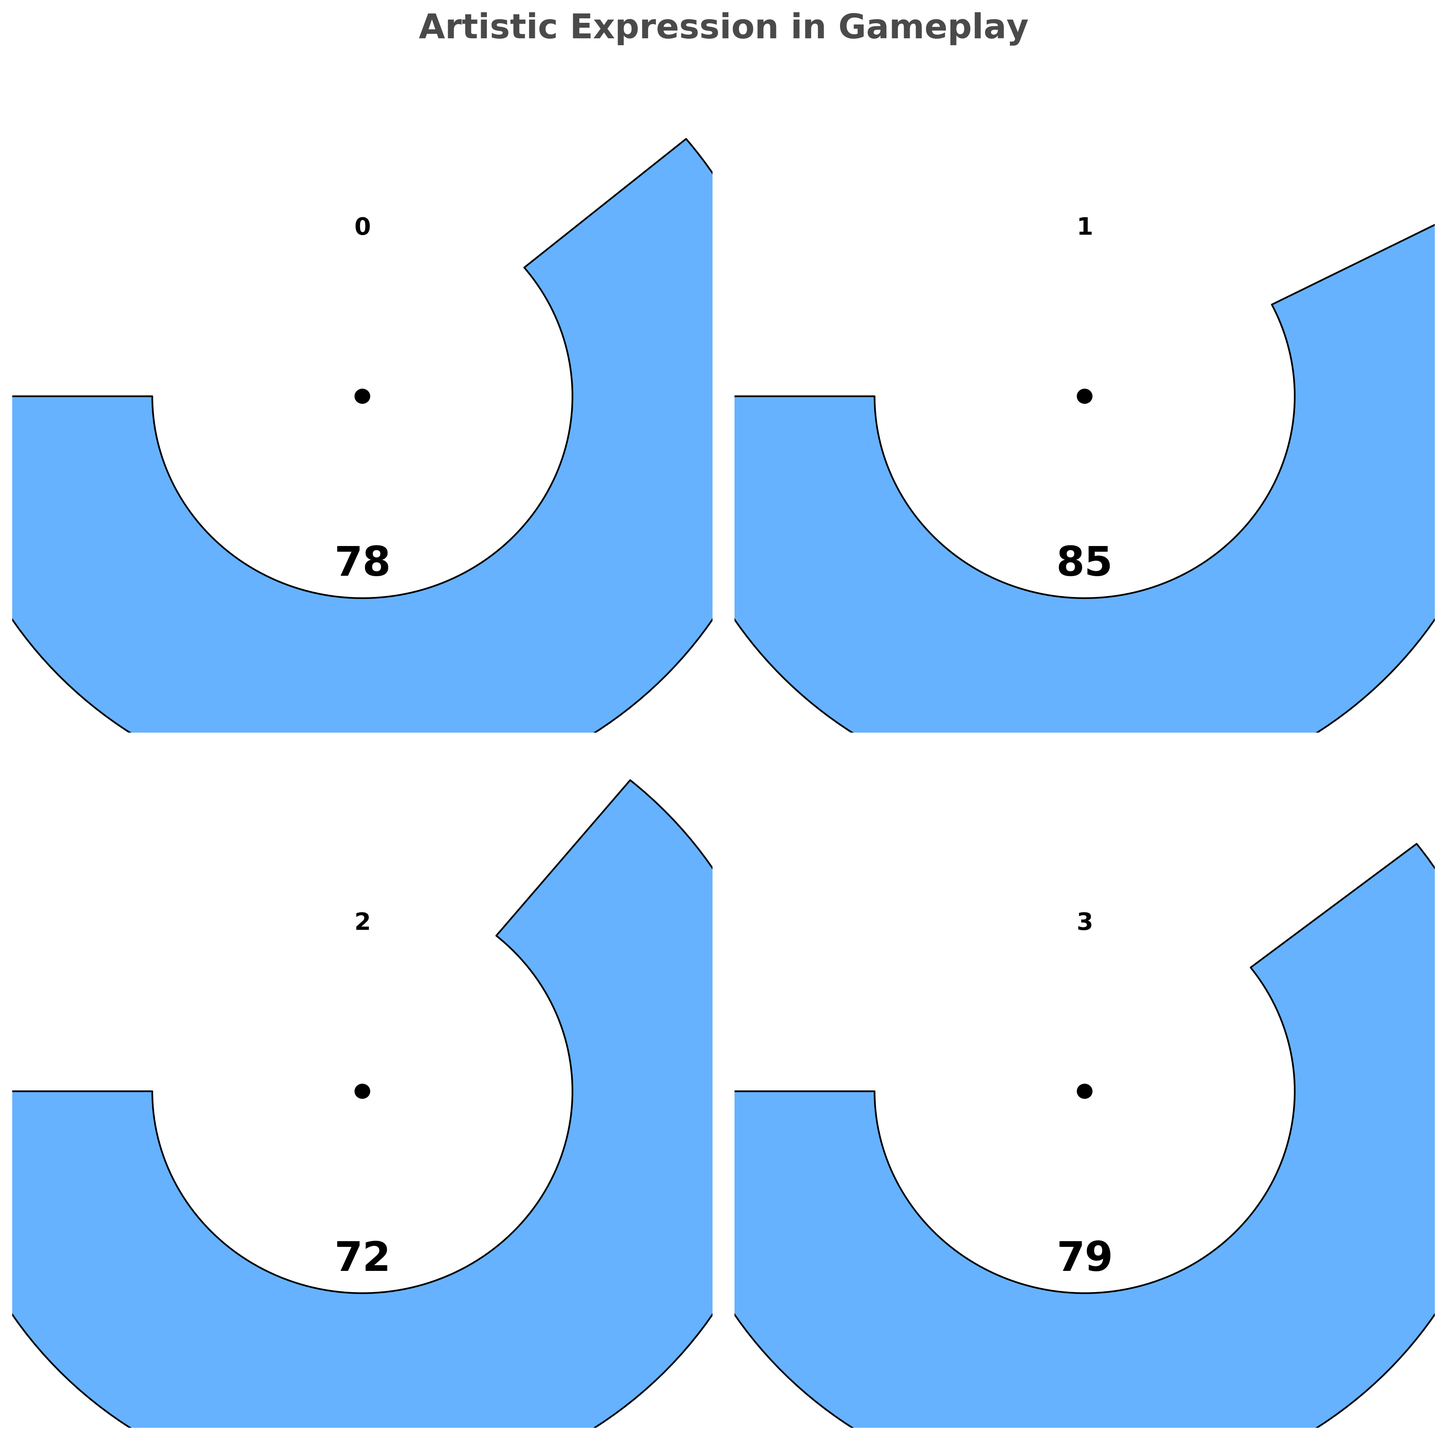what is the overall artistic expression value? The overall artistic expression value is directly displayed on the gauge chart labeled "Overall Artistic Expression".
Answer: 79 Which attribute has the highest value? Compare the Flair Moves, No-look Passes, and Unconventional Shots values. No-look Passes has the highest value at 85.
Answer: No-look Passes What color is used to represent the Unconventional Shots gauge? Look at the color used in the gauge chart for Unconventional Shots. It is a greenish shade.
Answer: Green How does the value of Flair Moves compare to Unconventional Shots? Flair Moves has a value of 78, while Unconventional Shots has a value of 72. Flair Moves is greater than Unconventional Shots.
Answer: Flair Moves is greater What is the average value of Flair Moves, No-look Passes, and Unconventional Shots? Add up the values of Flair Moves (78), No-look Passes (85), and Unconventional Shots (72), then divide by 3: (78 + 85 + 72)/3.
Answer: 78.33 What is the difference between the No-look Passes value and the flair moves value? Subtract the value of Flair Moves (78) from No-look Passes (85): 85 - 78.
Answer: 7 If you combine the values of all attributes except the overall artistic expression, what would the total be? Add the values of Flair Moves (78), No-look Passes (85), and Unconventional Shots (72): 78 + 85 + 72.
Answer: 235 Is the value of Overall Artistic Expression closer to No-look Passes or Unconventional Shots? Compare the differences: 85 - 79 = 6 (for No-look Passes) and 79 - 72 = 7 (for Unconventional Shots).
Answer: No-look Passes 